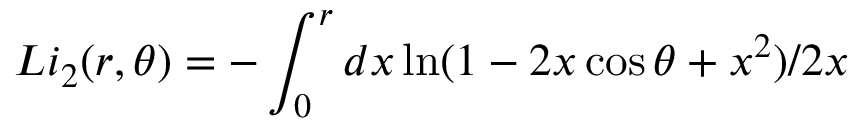<formula> <loc_0><loc_0><loc_500><loc_500>L i _ { 2 } ( r , \theta ) = - \int _ { 0 } ^ { r } d x \ln ( 1 - 2 x \cos \theta + x ^ { 2 } ) / 2 x</formula> 